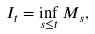Convert formula to latex. <formula><loc_0><loc_0><loc_500><loc_500>I _ { t } = \inf _ { s \leq t } M _ { s } ,</formula> 